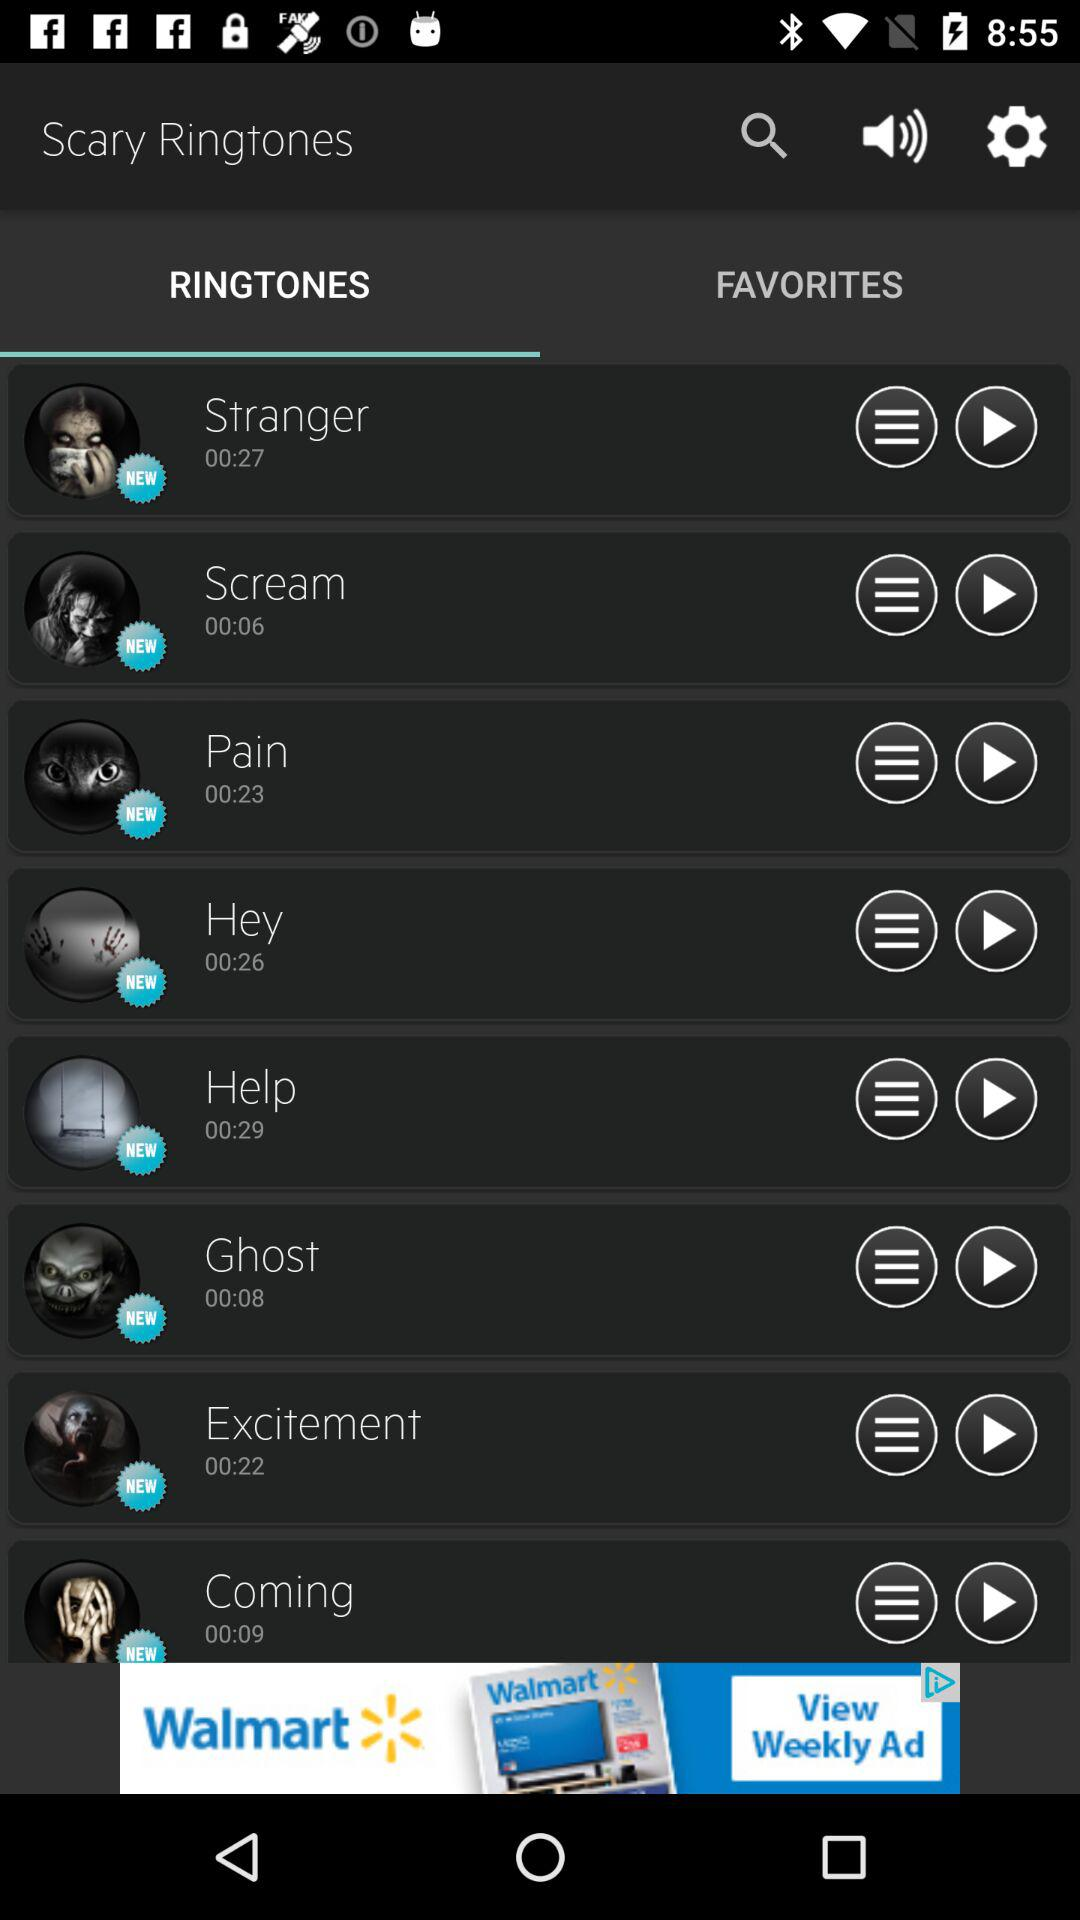What is the duration of the ringtone "Pain"? The duration is 23 seconds. 